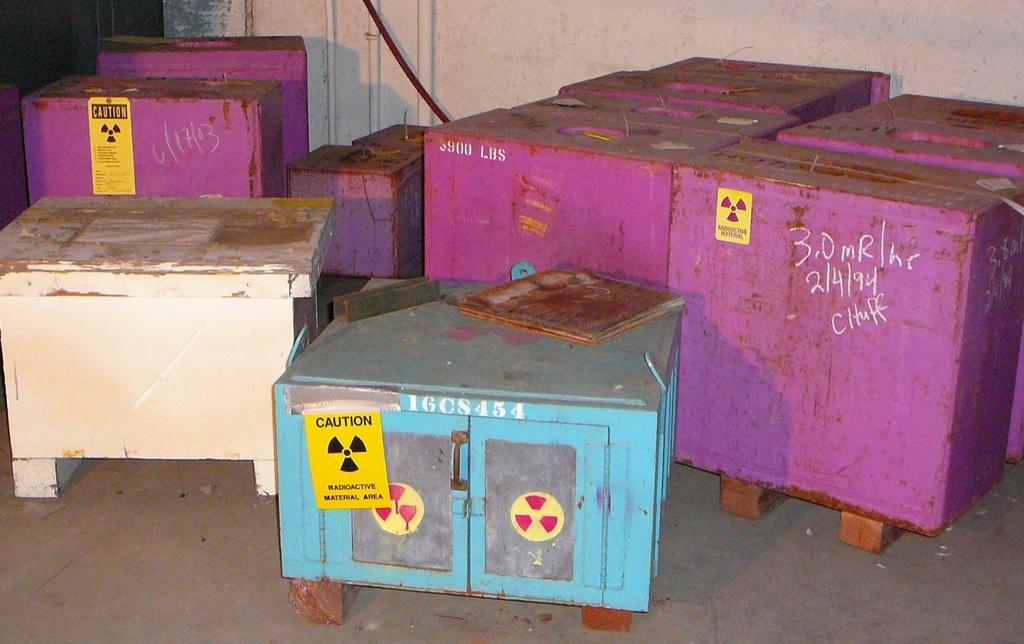What is the date on the purple container on the right?
Your answer should be very brief. 2/4/94. How much does the purple container weigh?
Your response must be concise. 3900 lbs. 